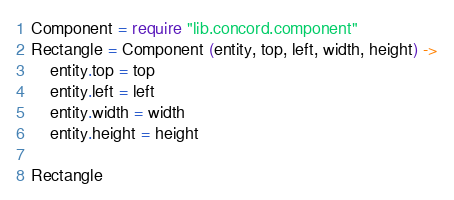<code> <loc_0><loc_0><loc_500><loc_500><_MoonScript_>Component = require "lib.concord.component"
Rectangle = Component (entity, top, left, width, height) ->
	entity.top = top
	entity.left = left
	entity.width = width
	entity.height = height

Rectangle</code> 